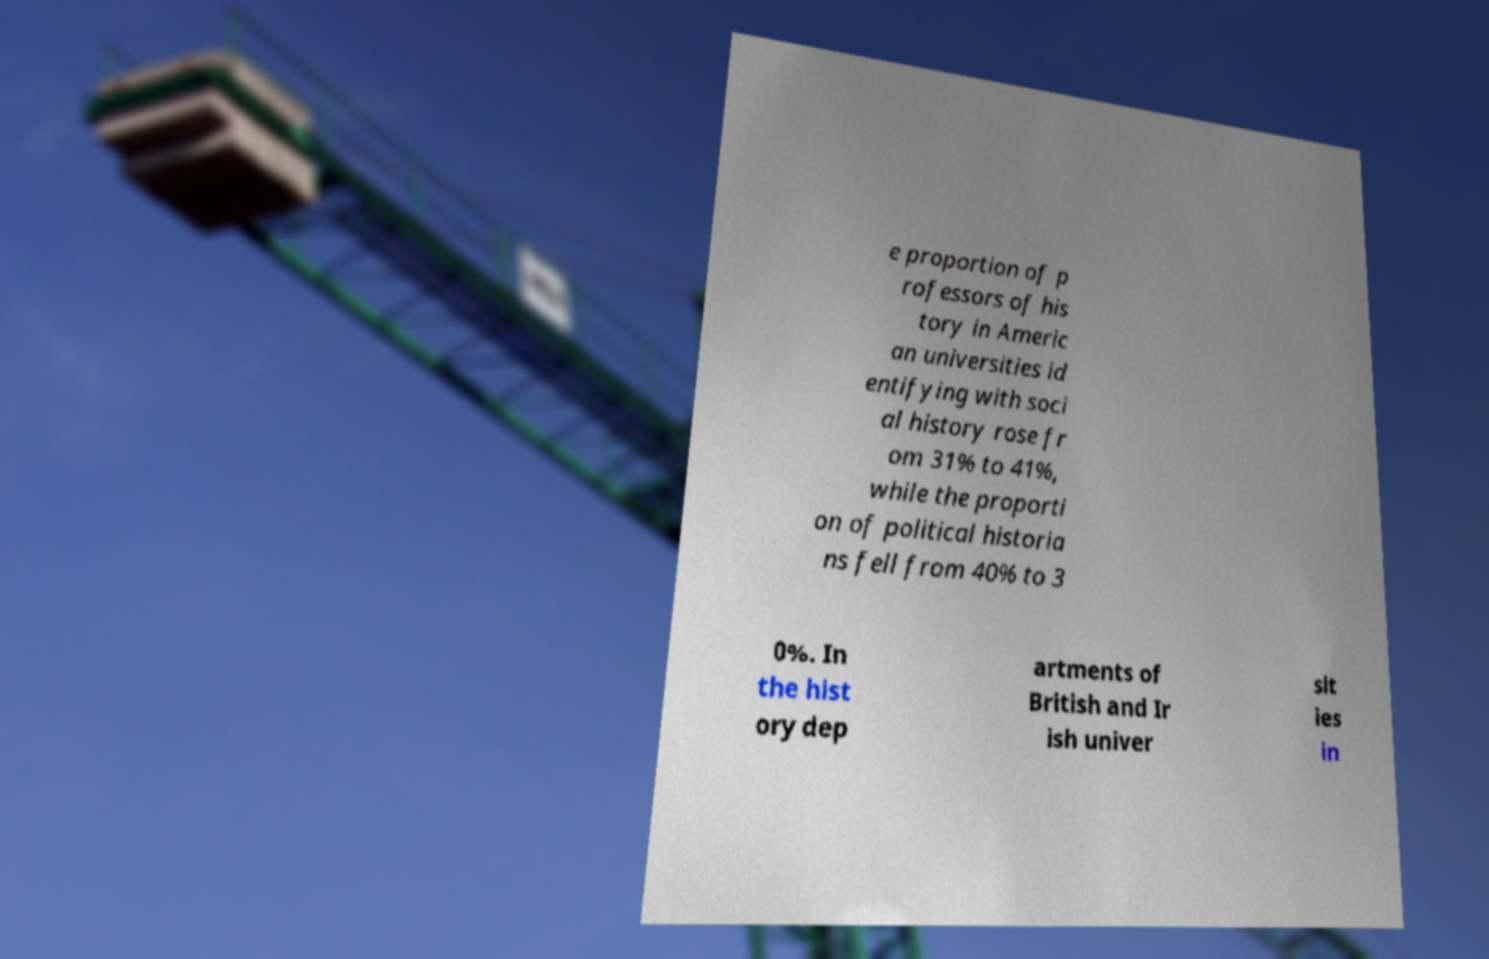I need the written content from this picture converted into text. Can you do that? e proportion of p rofessors of his tory in Americ an universities id entifying with soci al history rose fr om 31% to 41%, while the proporti on of political historia ns fell from 40% to 3 0%. In the hist ory dep artments of British and Ir ish univer sit ies in 